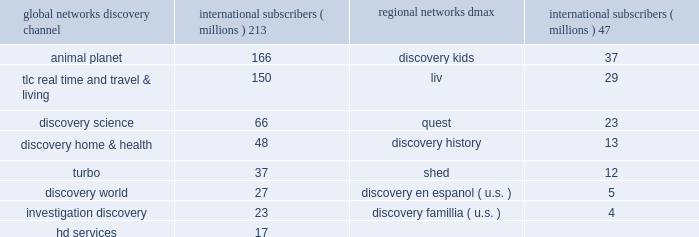Our digital media business consists of our websites and mobile and video-on-demand ( 201cvod 201d ) services .
Our websites include network branded websites such as discovery.com , tlc.com and animalplanet.com , and other websites such as howstuffworks.com , an online source of explanations of how the world actually works ; treehugger.com , a comprehensive source for 201cgreen 201d news , solutions and product information ; and petfinder.com , a leading pet adoption destination .
Together , these websites attracted an average of 24 million cumulative unique monthly visitors , according to comscore , inc .
In 2011 .
International networks our international networks segment principally consists of national and pan-regional television networks .
This segment generates revenues primarily from fees charged to operators who distribute our networks , which primarily include cable and dth satellite service providers , and from advertising sold on our television networks and websites .
Discovery channel , animal planet and tlc lead the international networks 2019 portfolio of television networks , which are distributed in virtually every pay-television market in the world through an infrastructure that includes operational centers in london , singapore and miami .
International networks has one of the largest international distribution platforms of networks with one to twelve networks in more than 200 countries and territories around the world .
At december 31 , 2011 , international networks operated over 150 unique distribution feeds in over 40 languages with channel feeds customized according to language needs and advertising sales opportunities .
Our international networks segment owns and operates the following television networks which reached the following number of subscribers as of december 31 , 2011 : education and other our education and other segment primarily includes the sale of curriculum-based product and service offerings and postproduction audio services .
This segment generates revenues primarily from subscriptions charged to k-12 schools for access to an online suite of curriculum-based vod tools , professional development services , and to a lesser extent student assessment and publication of hardcopy curriculum-based content .
Our education business also participates in corporate partnerships , global brand and content licensing business with leading non-profits , foundations and trade associations .
Other businesses primarily include postproduction audio services that are provided to major motion picture studios , independent producers , broadcast networks , cable channels , advertising agencies , and interactive producers .
Content development our content development strategy is designed to increase viewership , maintain innovation and quality leadership , and provide value for our network distributors and advertising customers .
Substantially all content is sourced from a wide range of third-party producers , which includes some of the world 2019s leading nonfiction production companies with which we have developed long-standing relationships , as well as independent producers .
Our production arrangements fall into three categories : produced , coproduced and licensed .
Substantially all produced content includes programming which we engage third parties to develop and produce while we retain editorial control and own most or all of the rights in exchange for paying all development and production costs .
Coproduced content refers to program rights acquired that we have collaborated with third parties to finance and develop .
Coproduced programs are typically high-cost projects for which neither we nor our coproducers wish to bear the entire cost or productions in which the producer has already taken on an international broadcast partner .
Licensed content is comprised of films or series that have been previously produced by third parties .
Global networks international subscribers ( millions ) regional networks international subscribers ( millions ) .

What is the difference in millions of subscribers between discovery channel international subscribers and animal planet international subscribers? 
Computations: (213 - 166)
Answer: 47.0. 